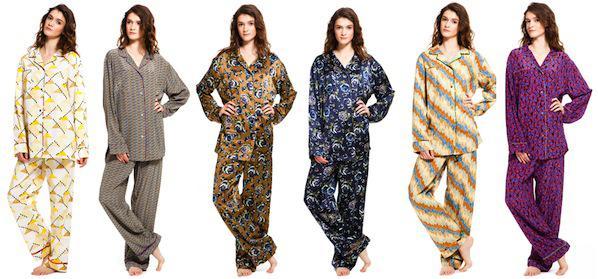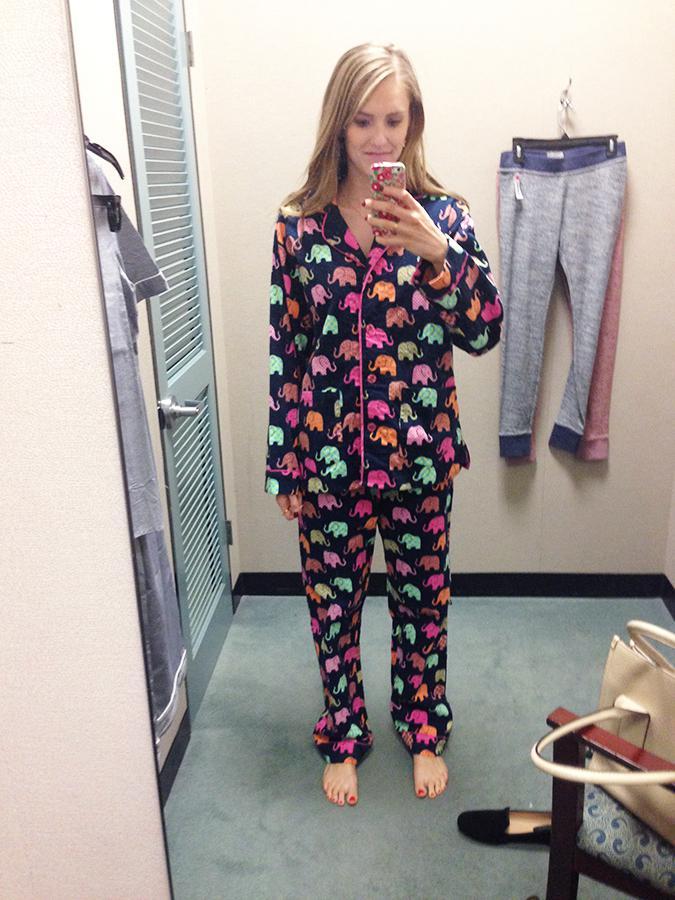The first image is the image on the left, the second image is the image on the right. Assess this claim about the two images: "there are models with legs showing". Correct or not? Answer yes or no. No. The first image is the image on the left, the second image is the image on the right. Analyze the images presented: Is the assertion "An image shows three models side-by-side, all wearing long-legged loungewear." valid? Answer yes or no. No. 